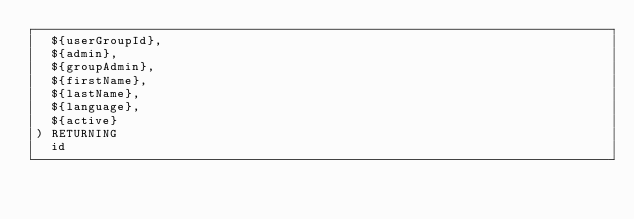Convert code to text. <code><loc_0><loc_0><loc_500><loc_500><_SQL_>  ${userGroupId},
  ${admin},
  ${groupAdmin},
  ${firstName},
  ${lastName},
  ${language},
  ${active}
) RETURNING 
  id
</code> 